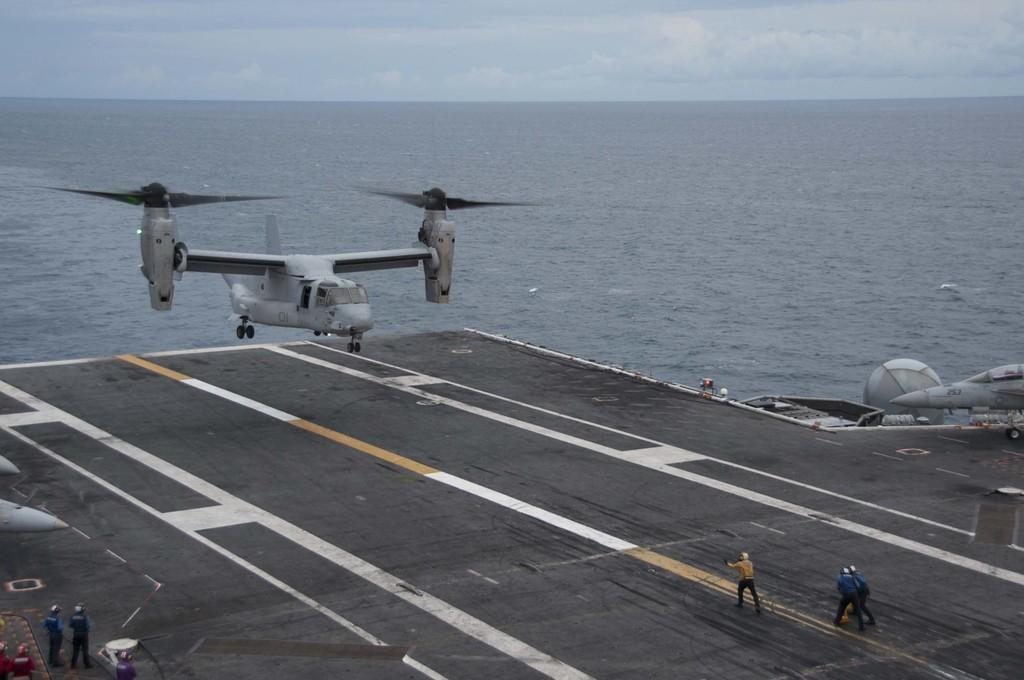What is the main subject of the image? The main subject of the image is airplanes. What can be seen in the background of the image? The sky is visible in the background of the image. What is the condition of the sky in the image? Clouds are present in the sky. What else is visible in the image besides the airplanes? There is water visible in the image, and there are people on the ground. Can you tell me how many tables are visible in the image? There are no tables present in the image. What type of river can be seen flowing through the image? There is no river visible in the image; it features airplanes, water, and people on the ground. 